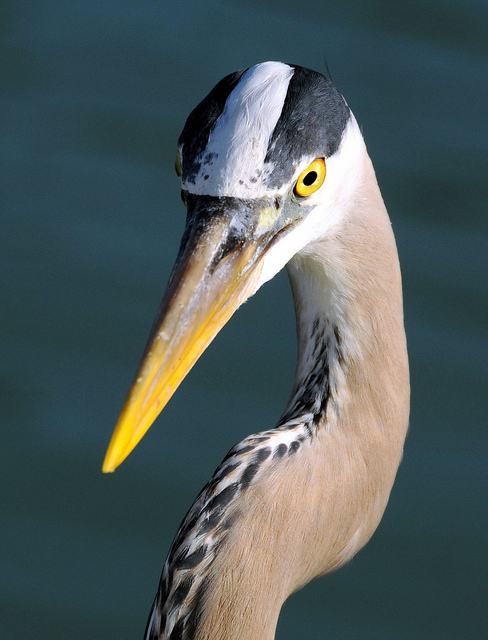What type of bird is this? This is a Grey Heron, identifiable by its long, yellow bill, contrasting black-and-white head, and gray body. Grey Herons are common in both wetlands and freshwater environments, where they hunt for fish and small amphibians. 